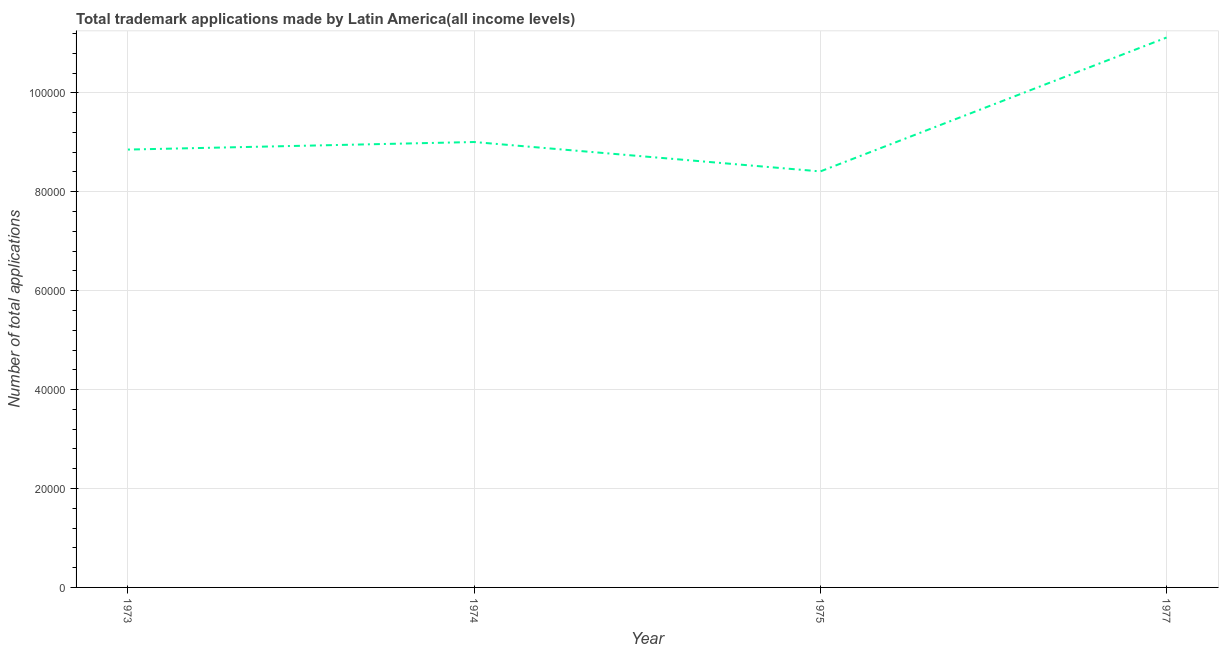What is the number of trademark applications in 1975?
Provide a short and direct response. 8.41e+04. Across all years, what is the maximum number of trademark applications?
Provide a succinct answer. 1.11e+05. Across all years, what is the minimum number of trademark applications?
Give a very brief answer. 8.41e+04. In which year was the number of trademark applications maximum?
Your answer should be compact. 1977. In which year was the number of trademark applications minimum?
Provide a short and direct response. 1975. What is the sum of the number of trademark applications?
Keep it short and to the point. 3.74e+05. What is the difference between the number of trademark applications in 1973 and 1975?
Your answer should be very brief. 4417. What is the average number of trademark applications per year?
Your answer should be compact. 9.35e+04. What is the median number of trademark applications?
Provide a short and direct response. 8.93e+04. Do a majority of the years between 1974 and 1973 (inclusive) have number of trademark applications greater than 56000 ?
Your response must be concise. No. What is the ratio of the number of trademark applications in 1973 to that in 1974?
Provide a short and direct response. 0.98. Is the number of trademark applications in 1973 less than that in 1977?
Keep it short and to the point. Yes. What is the difference between the highest and the second highest number of trademark applications?
Keep it short and to the point. 2.11e+04. Is the sum of the number of trademark applications in 1973 and 1975 greater than the maximum number of trademark applications across all years?
Make the answer very short. Yes. What is the difference between the highest and the lowest number of trademark applications?
Make the answer very short. 2.71e+04. Does the number of trademark applications monotonically increase over the years?
Offer a terse response. No. How many lines are there?
Offer a very short reply. 1. What is the difference between two consecutive major ticks on the Y-axis?
Ensure brevity in your answer.  2.00e+04. What is the title of the graph?
Your answer should be compact. Total trademark applications made by Latin America(all income levels). What is the label or title of the Y-axis?
Your response must be concise. Number of total applications. What is the Number of total applications in 1973?
Keep it short and to the point. 8.85e+04. What is the Number of total applications of 1974?
Provide a succinct answer. 9.01e+04. What is the Number of total applications of 1975?
Offer a very short reply. 8.41e+04. What is the Number of total applications in 1977?
Give a very brief answer. 1.11e+05. What is the difference between the Number of total applications in 1973 and 1974?
Your response must be concise. -1526. What is the difference between the Number of total applications in 1973 and 1975?
Your response must be concise. 4417. What is the difference between the Number of total applications in 1973 and 1977?
Your response must be concise. -2.27e+04. What is the difference between the Number of total applications in 1974 and 1975?
Offer a terse response. 5943. What is the difference between the Number of total applications in 1974 and 1977?
Keep it short and to the point. -2.11e+04. What is the difference between the Number of total applications in 1975 and 1977?
Your answer should be compact. -2.71e+04. What is the ratio of the Number of total applications in 1973 to that in 1974?
Ensure brevity in your answer.  0.98. What is the ratio of the Number of total applications in 1973 to that in 1975?
Make the answer very short. 1.05. What is the ratio of the Number of total applications in 1973 to that in 1977?
Offer a terse response. 0.8. What is the ratio of the Number of total applications in 1974 to that in 1975?
Offer a terse response. 1.07. What is the ratio of the Number of total applications in 1974 to that in 1977?
Your answer should be compact. 0.81. What is the ratio of the Number of total applications in 1975 to that in 1977?
Provide a short and direct response. 0.76. 